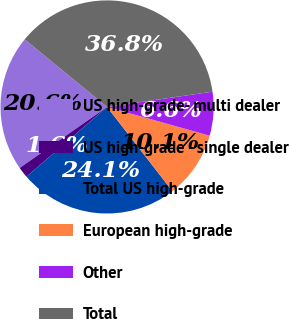Convert chart to OTSL. <chart><loc_0><loc_0><loc_500><loc_500><pie_chart><fcel>US high-grade- multi dealer<fcel>US high-grade - single dealer<fcel>Total US high-grade<fcel>European high-grade<fcel>Other<fcel>Total<nl><fcel>20.64%<fcel>1.65%<fcel>24.15%<fcel>10.15%<fcel>6.64%<fcel>36.78%<nl></chart> 